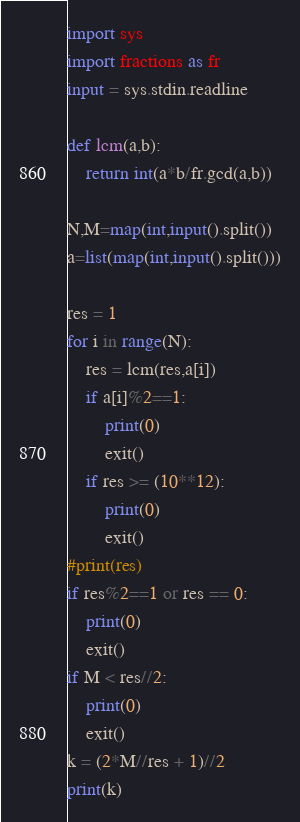<code> <loc_0><loc_0><loc_500><loc_500><_Python_>import sys
import fractions as fr
input = sys.stdin.readline

def lcm(a,b):
    return int(a*b/fr.gcd(a,b))

N,M=map(int,input().split())
a=list(map(int,input().split()))

res = 1
for i in range(N):
    res = lcm(res,a[i])
    if a[i]%2==1:
        print(0)
        exit()
    if res >= (10**12):
        print(0)
        exit()
#print(res)
if res%2==1 or res == 0:
    print(0)
    exit()
if M < res//2:
    print(0)
    exit()
k = (2*M//res + 1)//2
print(k)
</code> 